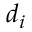Convert formula to latex. <formula><loc_0><loc_0><loc_500><loc_500>d _ { i }</formula> 